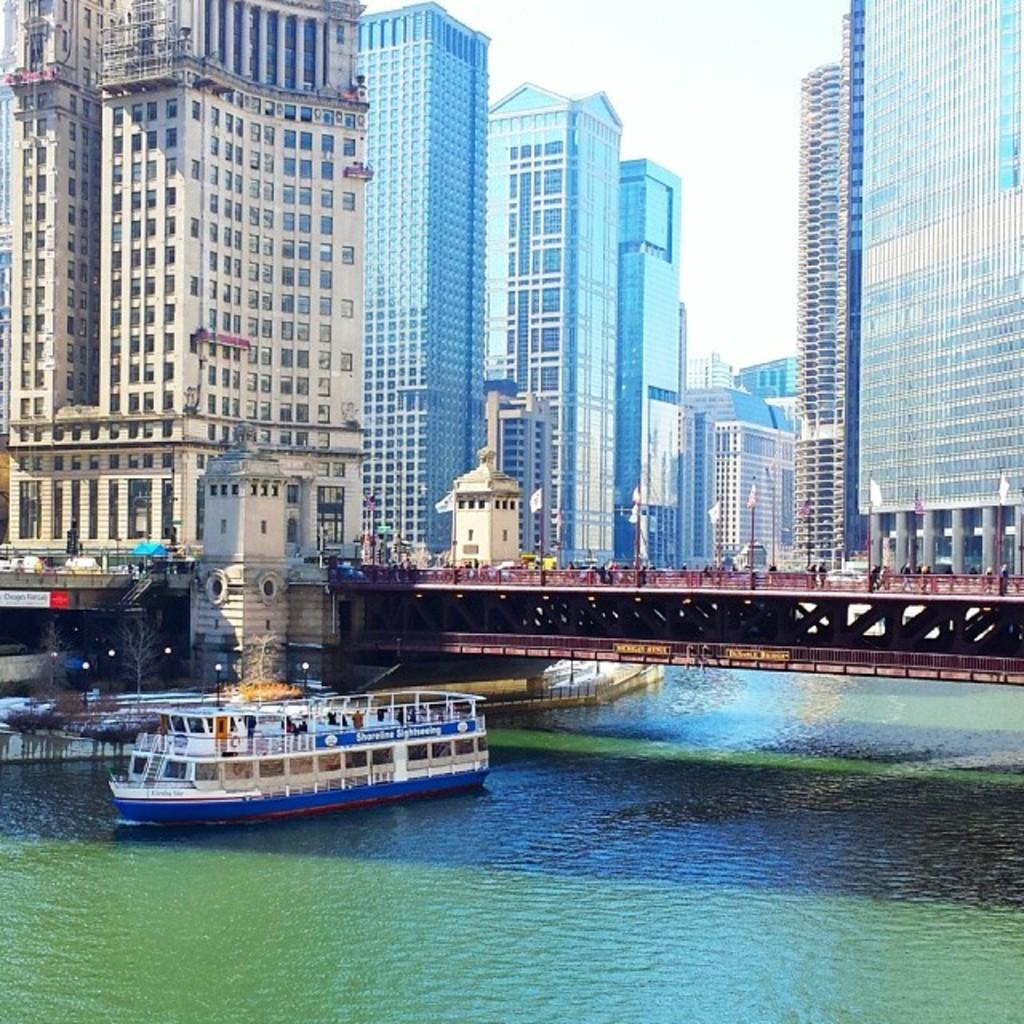What is located on the left side of the image? There is a boat on the water on the left side of the image. What is above the boat in the image? There is a bridge above the boat. What can be seen in the background of the image? There are buildings and clouds in the sky in the background of the image. How many potatoes can be seen on the bridge in the image? There are no potatoes present in the image; the bridge is above the boat on the water. What sense is being used by the boat in the image? Boats do not have senses; they are inanimate objects. 